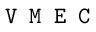<formula> <loc_0><loc_0><loc_500><loc_500>V M E C</formula> 